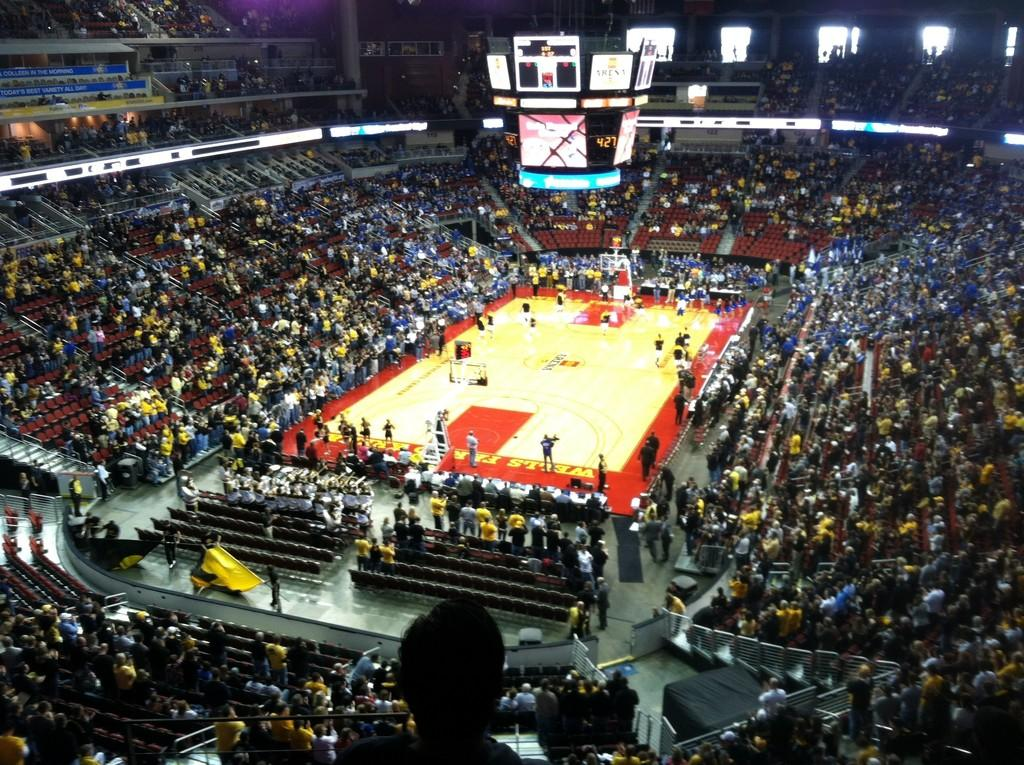<image>
Write a terse but informative summary of the picture. A basketball court has advertisements for Wells Fargo on either end of the hardwood floor. 